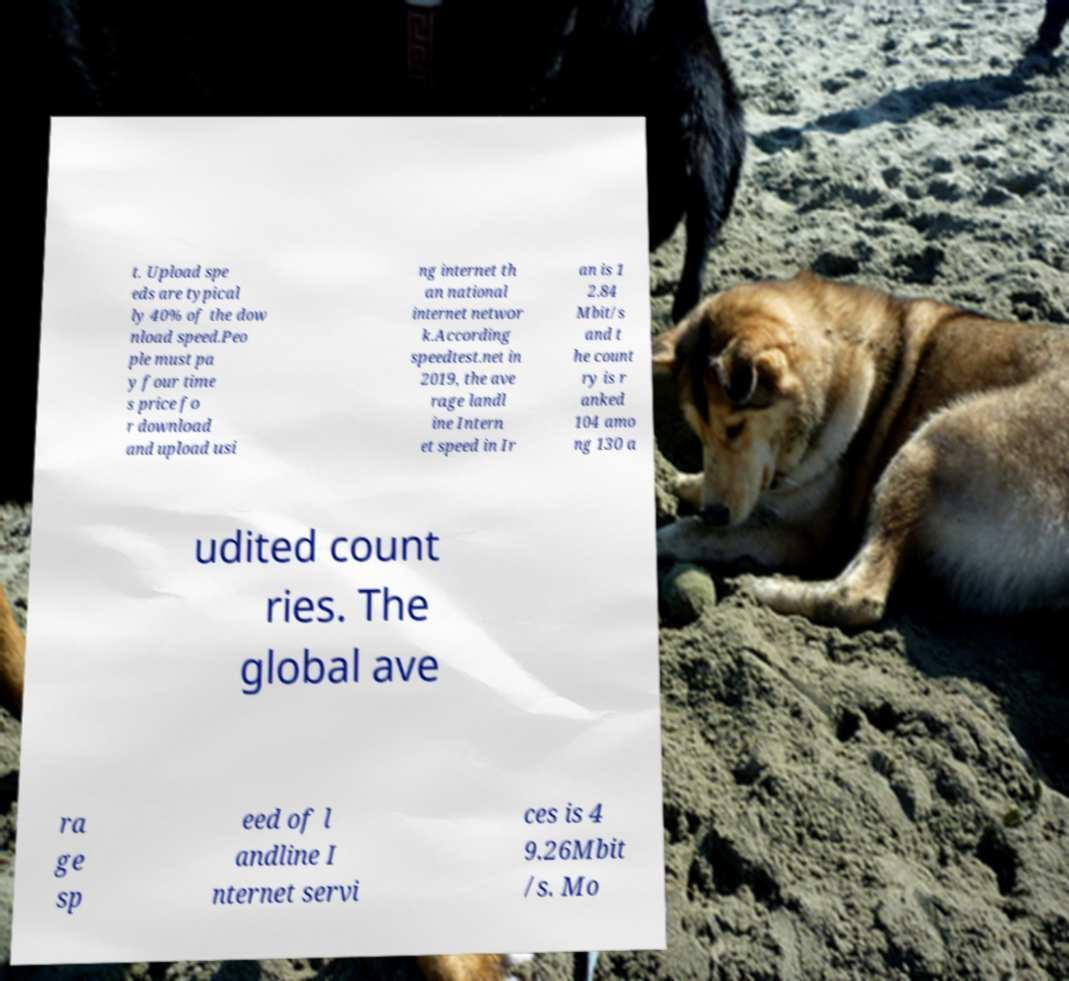There's text embedded in this image that I need extracted. Can you transcribe it verbatim? t. Upload spe eds are typical ly 40% of the dow nload speed.Peo ple must pa y four time s price fo r download and upload usi ng internet th an national internet networ k.According speedtest.net in 2019, the ave rage landl ine Intern et speed in Ir an is 1 2.84 Mbit/s and t he count ry is r anked 104 amo ng 130 a udited count ries. The global ave ra ge sp eed of l andline I nternet servi ces is 4 9.26Mbit /s. Mo 